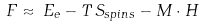Convert formula to latex. <formula><loc_0><loc_0><loc_500><loc_500>F \approx \, E _ { e } - T \, S _ { s p i n s } - { M \cdot H }</formula> 